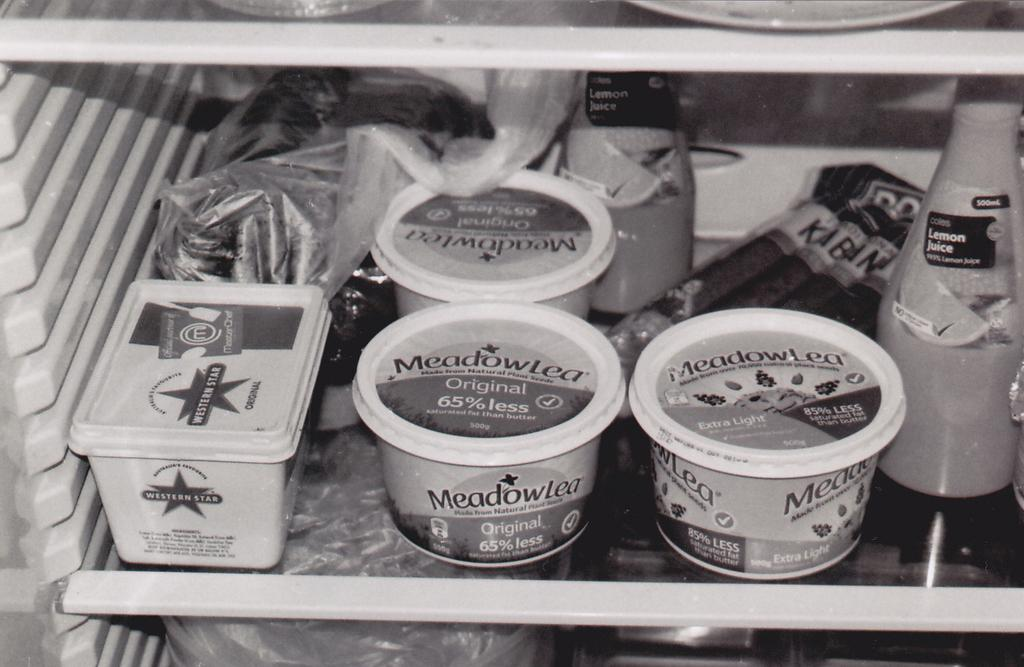What type of appliance is visible in the image? There is a refrigerator in the image. What is inside the refrigerator? There are objects arranged in the refrigerator. Can you see a bridge connecting two sides of the refrigerator in the image? There is no bridge connecting two sides of the refrigerator in the image. How many ladybugs are crawling on the objects inside the refrigerator? There are no ladybugs present in the image. 